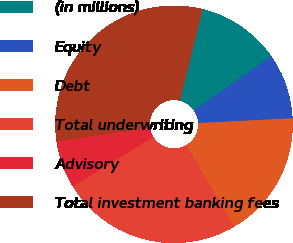Convert chart to OTSL. <chart><loc_0><loc_0><loc_500><loc_500><pie_chart><fcel>(in millions)<fcel>Equity<fcel>Debt<fcel>Total underwriting<fcel>Advisory<fcel>Total investment banking fees<nl><fcel>11.4%<fcel>8.93%<fcel>17.35%<fcel>24.7%<fcel>6.46%<fcel>31.16%<nl></chart> 